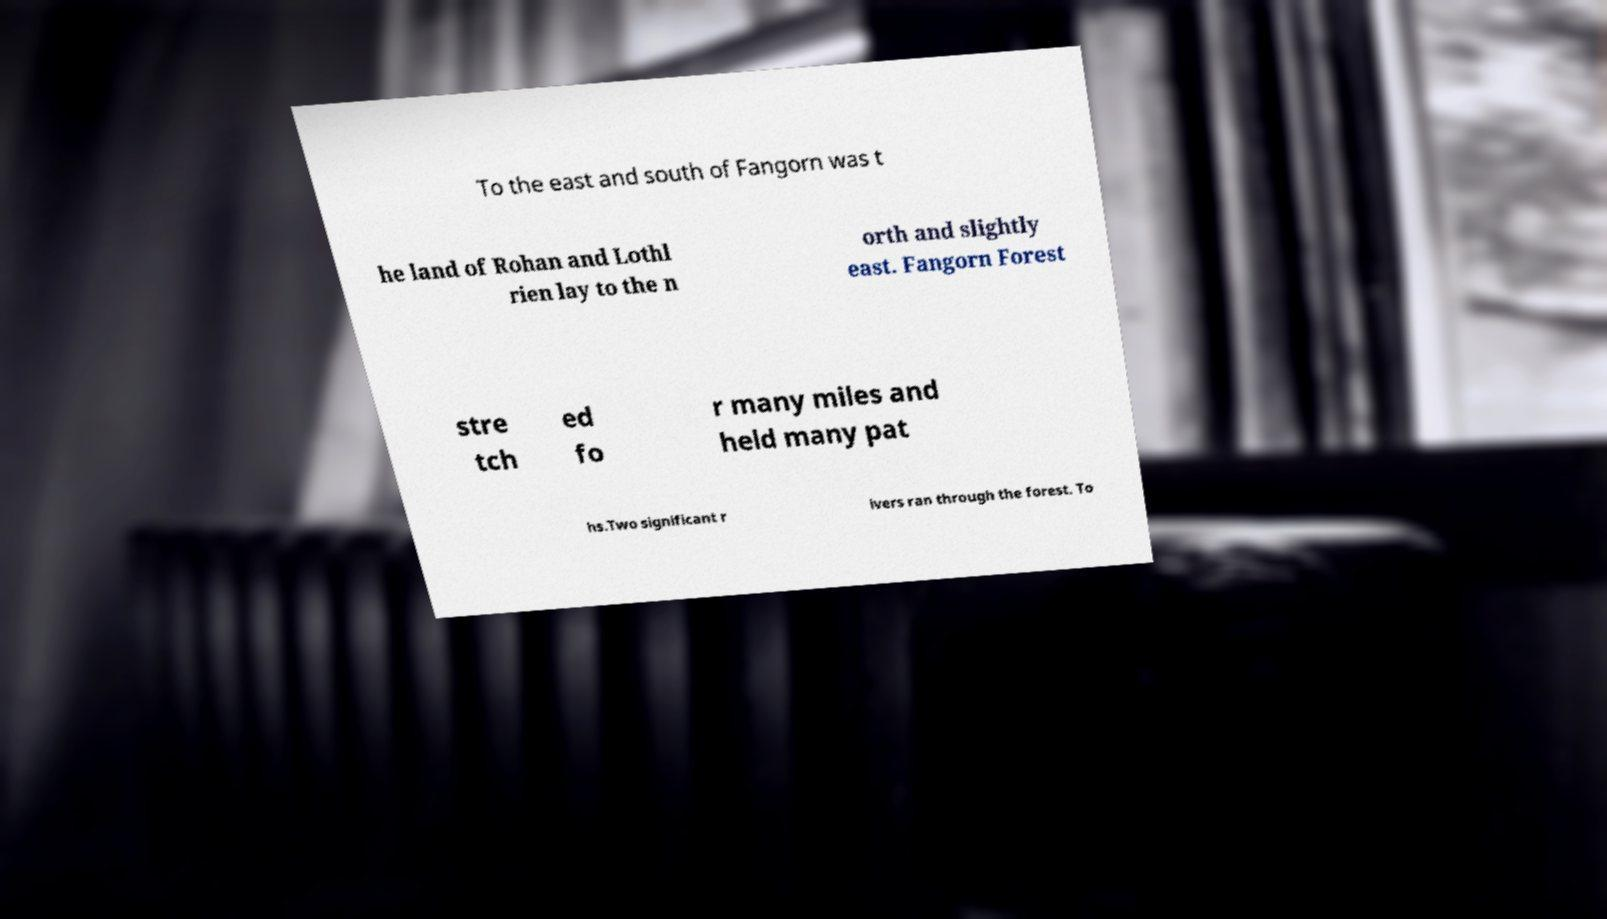There's text embedded in this image that I need extracted. Can you transcribe it verbatim? To the east and south of Fangorn was t he land of Rohan and Lothl rien lay to the n orth and slightly east. Fangorn Forest stre tch ed fo r many miles and held many pat hs.Two significant r ivers ran through the forest. To 